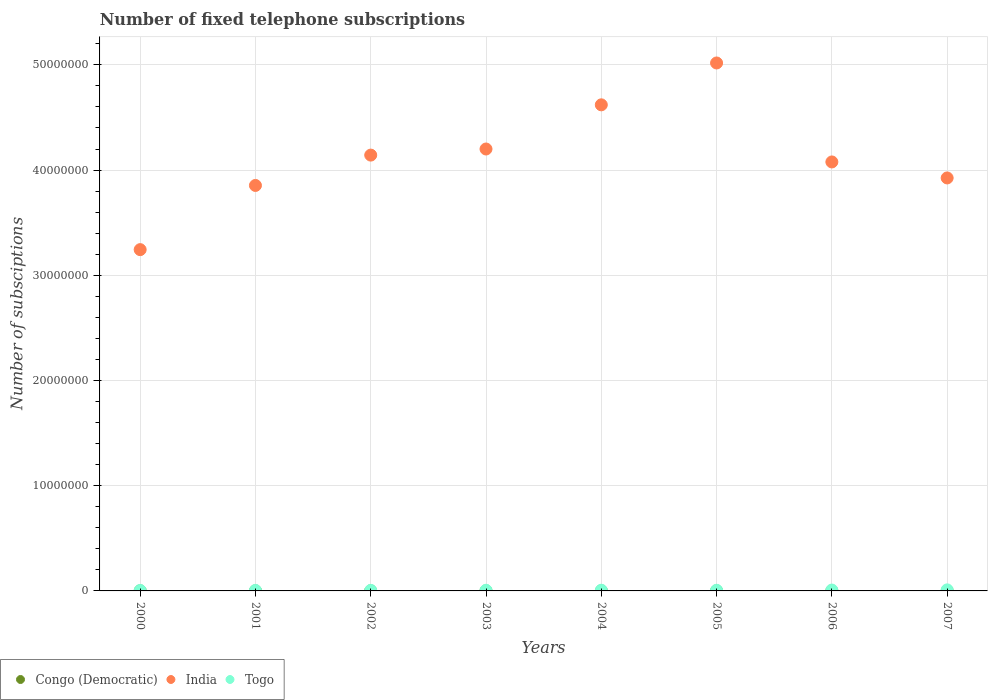How many different coloured dotlines are there?
Make the answer very short. 3. What is the number of fixed telephone subscriptions in India in 2005?
Make the answer very short. 5.02e+07. Across all years, what is the maximum number of fixed telephone subscriptions in India?
Your response must be concise. 5.02e+07. Across all years, what is the minimum number of fixed telephone subscriptions in India?
Offer a terse response. 3.24e+07. In which year was the number of fixed telephone subscriptions in India maximum?
Provide a succinct answer. 2005. In which year was the number of fixed telephone subscriptions in Togo minimum?
Offer a terse response. 2000. What is the total number of fixed telephone subscriptions in India in the graph?
Offer a very short reply. 3.31e+08. What is the difference between the number of fixed telephone subscriptions in India in 2002 and that in 2007?
Provide a short and direct response. 2.17e+06. What is the difference between the number of fixed telephone subscriptions in India in 2000 and the number of fixed telephone subscriptions in Congo (Democratic) in 2001?
Your answer should be compact. 3.24e+07. What is the average number of fixed telephone subscriptions in Congo (Democratic) per year?
Make the answer very short. 9228.25. In the year 2004, what is the difference between the number of fixed telephone subscriptions in India and number of fixed telephone subscriptions in Togo?
Make the answer very short. 4.61e+07. What is the ratio of the number of fixed telephone subscriptions in Congo (Democratic) in 2001 to that in 2006?
Ensure brevity in your answer.  1.03. Is the number of fixed telephone subscriptions in Congo (Democratic) in 2002 less than that in 2004?
Your response must be concise. Yes. Is the difference between the number of fixed telephone subscriptions in India in 2002 and 2005 greater than the difference between the number of fixed telephone subscriptions in Togo in 2002 and 2005?
Give a very brief answer. No. What is the difference between the highest and the lowest number of fixed telephone subscriptions in Congo (Democratic)?
Give a very brief answer. 7079. In how many years, is the number of fixed telephone subscriptions in Congo (Democratic) greater than the average number of fixed telephone subscriptions in Congo (Democratic) taken over all years?
Your answer should be compact. 7. Is the sum of the number of fixed telephone subscriptions in Congo (Democratic) in 2000 and 2001 greater than the maximum number of fixed telephone subscriptions in India across all years?
Provide a short and direct response. No. Is the number of fixed telephone subscriptions in Congo (Democratic) strictly greater than the number of fixed telephone subscriptions in India over the years?
Your answer should be compact. No. Does the graph contain any zero values?
Your answer should be very brief. No. Does the graph contain grids?
Provide a short and direct response. Yes. Where does the legend appear in the graph?
Offer a very short reply. Bottom left. What is the title of the graph?
Provide a succinct answer. Number of fixed telephone subscriptions. What is the label or title of the Y-axis?
Your answer should be very brief. Number of subsciptions. What is the Number of subsciptions of Congo (Democratic) in 2000?
Provide a short and direct response. 9810. What is the Number of subsciptions of India in 2000?
Your response must be concise. 3.24e+07. What is the Number of subsciptions in Togo in 2000?
Provide a short and direct response. 4.28e+04. What is the Number of subsciptions of Congo (Democratic) in 2001?
Give a very brief answer. 9980. What is the Number of subsciptions of India in 2001?
Offer a terse response. 3.85e+07. What is the Number of subsciptions in Togo in 2001?
Provide a succinct answer. 4.84e+04. What is the Number of subsciptions in India in 2002?
Your response must be concise. 4.14e+07. What is the Number of subsciptions of Togo in 2002?
Give a very brief answer. 5.12e+04. What is the Number of subsciptions in Congo (Democratic) in 2003?
Your answer should be compact. 9733. What is the Number of subsciptions in India in 2003?
Offer a very short reply. 4.20e+07. What is the Number of subsciptions in Togo in 2003?
Offer a very short reply. 6.11e+04. What is the Number of subsciptions of Congo (Democratic) in 2004?
Your answer should be compact. 1.05e+04. What is the Number of subsciptions in India in 2004?
Offer a terse response. 4.62e+07. What is the Number of subsciptions of Togo in 2004?
Offer a very short reply. 6.59e+04. What is the Number of subsciptions of Congo (Democratic) in 2005?
Your answer should be very brief. 1.06e+04. What is the Number of subsciptions in India in 2005?
Provide a succinct answer. 5.02e+07. What is the Number of subsciptions of Togo in 2005?
Provide a short and direct response. 6.28e+04. What is the Number of subsciptions in Congo (Democratic) in 2006?
Offer a very short reply. 9700. What is the Number of subsciptions of India in 2006?
Offer a very short reply. 4.08e+07. What is the Number of subsciptions of Togo in 2006?
Your answer should be very brief. 8.21e+04. What is the Number of subsciptions of Congo (Democratic) in 2007?
Your response must be concise. 3500. What is the Number of subsciptions of India in 2007?
Provide a short and direct response. 3.92e+07. What is the Number of subsciptions in Togo in 2007?
Keep it short and to the point. 9.95e+04. Across all years, what is the maximum Number of subsciptions of Congo (Democratic)?
Offer a very short reply. 1.06e+04. Across all years, what is the maximum Number of subsciptions in India?
Keep it short and to the point. 5.02e+07. Across all years, what is the maximum Number of subsciptions of Togo?
Provide a short and direct response. 9.95e+04. Across all years, what is the minimum Number of subsciptions of Congo (Democratic)?
Provide a succinct answer. 3500. Across all years, what is the minimum Number of subsciptions in India?
Keep it short and to the point. 3.24e+07. Across all years, what is the minimum Number of subsciptions of Togo?
Offer a terse response. 4.28e+04. What is the total Number of subsciptions in Congo (Democratic) in the graph?
Provide a succinct answer. 7.38e+04. What is the total Number of subsciptions of India in the graph?
Keep it short and to the point. 3.31e+08. What is the total Number of subsciptions of Togo in the graph?
Ensure brevity in your answer.  5.14e+05. What is the difference between the Number of subsciptions of Congo (Democratic) in 2000 and that in 2001?
Provide a short and direct response. -170. What is the difference between the Number of subsciptions of India in 2000 and that in 2001?
Keep it short and to the point. -6.10e+06. What is the difference between the Number of subsciptions in Togo in 2000 and that in 2001?
Your answer should be very brief. -5621. What is the difference between the Number of subsciptions in Congo (Democratic) in 2000 and that in 2002?
Ensure brevity in your answer.  -190. What is the difference between the Number of subsciptions of India in 2000 and that in 2002?
Provide a succinct answer. -8.98e+06. What is the difference between the Number of subsciptions in Togo in 2000 and that in 2002?
Offer a terse response. -8393. What is the difference between the Number of subsciptions in Congo (Democratic) in 2000 and that in 2003?
Your answer should be compact. 77. What is the difference between the Number of subsciptions in India in 2000 and that in 2003?
Keep it short and to the point. -9.56e+06. What is the difference between the Number of subsciptions in Togo in 2000 and that in 2003?
Make the answer very short. -1.83e+04. What is the difference between the Number of subsciptions in Congo (Democratic) in 2000 and that in 2004?
Give a very brief answer. -714. What is the difference between the Number of subsciptions of India in 2000 and that in 2004?
Offer a very short reply. -1.38e+07. What is the difference between the Number of subsciptions of Togo in 2000 and that in 2004?
Offer a terse response. -2.32e+04. What is the difference between the Number of subsciptions in Congo (Democratic) in 2000 and that in 2005?
Give a very brief answer. -769. What is the difference between the Number of subsciptions in India in 2000 and that in 2005?
Offer a very short reply. -1.77e+07. What is the difference between the Number of subsciptions in Togo in 2000 and that in 2005?
Make the answer very short. -2.01e+04. What is the difference between the Number of subsciptions in Congo (Democratic) in 2000 and that in 2006?
Offer a very short reply. 110. What is the difference between the Number of subsciptions in India in 2000 and that in 2006?
Your response must be concise. -8.33e+06. What is the difference between the Number of subsciptions in Togo in 2000 and that in 2006?
Your response must be concise. -3.93e+04. What is the difference between the Number of subsciptions of Congo (Democratic) in 2000 and that in 2007?
Ensure brevity in your answer.  6310. What is the difference between the Number of subsciptions of India in 2000 and that in 2007?
Ensure brevity in your answer.  -6.81e+06. What is the difference between the Number of subsciptions of Togo in 2000 and that in 2007?
Ensure brevity in your answer.  -5.67e+04. What is the difference between the Number of subsciptions in India in 2001 and that in 2002?
Give a very brief answer. -2.88e+06. What is the difference between the Number of subsciptions of Togo in 2001 and that in 2002?
Provide a succinct answer. -2772. What is the difference between the Number of subsciptions in Congo (Democratic) in 2001 and that in 2003?
Keep it short and to the point. 247. What is the difference between the Number of subsciptions in India in 2001 and that in 2003?
Provide a short and direct response. -3.46e+06. What is the difference between the Number of subsciptions of Togo in 2001 and that in 2003?
Offer a very short reply. -1.27e+04. What is the difference between the Number of subsciptions in Congo (Democratic) in 2001 and that in 2004?
Give a very brief answer. -544. What is the difference between the Number of subsciptions in India in 2001 and that in 2004?
Your response must be concise. -7.66e+06. What is the difference between the Number of subsciptions of Togo in 2001 and that in 2004?
Give a very brief answer. -1.76e+04. What is the difference between the Number of subsciptions of Congo (Democratic) in 2001 and that in 2005?
Make the answer very short. -599. What is the difference between the Number of subsciptions in India in 2001 and that in 2005?
Your response must be concise. -1.16e+07. What is the difference between the Number of subsciptions in Togo in 2001 and that in 2005?
Make the answer very short. -1.44e+04. What is the difference between the Number of subsciptions of Congo (Democratic) in 2001 and that in 2006?
Keep it short and to the point. 280. What is the difference between the Number of subsciptions in India in 2001 and that in 2006?
Provide a succinct answer. -2.23e+06. What is the difference between the Number of subsciptions in Togo in 2001 and that in 2006?
Provide a short and direct response. -3.37e+04. What is the difference between the Number of subsciptions of Congo (Democratic) in 2001 and that in 2007?
Make the answer very short. 6480. What is the difference between the Number of subsciptions in India in 2001 and that in 2007?
Provide a short and direct response. -7.14e+05. What is the difference between the Number of subsciptions of Togo in 2001 and that in 2007?
Your response must be concise. -5.11e+04. What is the difference between the Number of subsciptions of Congo (Democratic) in 2002 and that in 2003?
Keep it short and to the point. 267. What is the difference between the Number of subsciptions of India in 2002 and that in 2003?
Offer a very short reply. -5.80e+05. What is the difference between the Number of subsciptions of Togo in 2002 and that in 2003?
Make the answer very short. -9943. What is the difference between the Number of subsciptions of Congo (Democratic) in 2002 and that in 2004?
Make the answer very short. -524. What is the difference between the Number of subsciptions in India in 2002 and that in 2004?
Ensure brevity in your answer.  -4.78e+06. What is the difference between the Number of subsciptions of Togo in 2002 and that in 2004?
Provide a short and direct response. -1.48e+04. What is the difference between the Number of subsciptions in Congo (Democratic) in 2002 and that in 2005?
Your answer should be very brief. -579. What is the difference between the Number of subsciptions in India in 2002 and that in 2005?
Your answer should be compact. -8.76e+06. What is the difference between the Number of subsciptions of Togo in 2002 and that in 2005?
Make the answer very short. -1.17e+04. What is the difference between the Number of subsciptions of Congo (Democratic) in 2002 and that in 2006?
Provide a short and direct response. 300. What is the difference between the Number of subsciptions in India in 2002 and that in 2006?
Your response must be concise. 6.50e+05. What is the difference between the Number of subsciptions of Togo in 2002 and that in 2006?
Give a very brief answer. -3.09e+04. What is the difference between the Number of subsciptions in Congo (Democratic) in 2002 and that in 2007?
Your response must be concise. 6500. What is the difference between the Number of subsciptions of India in 2002 and that in 2007?
Ensure brevity in your answer.  2.17e+06. What is the difference between the Number of subsciptions of Togo in 2002 and that in 2007?
Keep it short and to the point. -4.83e+04. What is the difference between the Number of subsciptions in Congo (Democratic) in 2003 and that in 2004?
Make the answer very short. -791. What is the difference between the Number of subsciptions in India in 2003 and that in 2004?
Make the answer very short. -4.20e+06. What is the difference between the Number of subsciptions in Togo in 2003 and that in 2004?
Keep it short and to the point. -4850. What is the difference between the Number of subsciptions of Congo (Democratic) in 2003 and that in 2005?
Your answer should be very brief. -846. What is the difference between the Number of subsciptions in India in 2003 and that in 2005?
Provide a short and direct response. -8.18e+06. What is the difference between the Number of subsciptions in Togo in 2003 and that in 2005?
Your response must be concise. -1732. What is the difference between the Number of subsciptions in Congo (Democratic) in 2003 and that in 2006?
Ensure brevity in your answer.  33. What is the difference between the Number of subsciptions of India in 2003 and that in 2006?
Your answer should be very brief. 1.23e+06. What is the difference between the Number of subsciptions in Togo in 2003 and that in 2006?
Your answer should be compact. -2.10e+04. What is the difference between the Number of subsciptions in Congo (Democratic) in 2003 and that in 2007?
Provide a succinct answer. 6233. What is the difference between the Number of subsciptions in India in 2003 and that in 2007?
Your response must be concise. 2.75e+06. What is the difference between the Number of subsciptions of Togo in 2003 and that in 2007?
Your answer should be compact. -3.84e+04. What is the difference between the Number of subsciptions of Congo (Democratic) in 2004 and that in 2005?
Ensure brevity in your answer.  -55. What is the difference between the Number of subsciptions of India in 2004 and that in 2005?
Ensure brevity in your answer.  -3.98e+06. What is the difference between the Number of subsciptions in Togo in 2004 and that in 2005?
Give a very brief answer. 3118. What is the difference between the Number of subsciptions in Congo (Democratic) in 2004 and that in 2006?
Your answer should be very brief. 824. What is the difference between the Number of subsciptions in India in 2004 and that in 2006?
Give a very brief answer. 5.43e+06. What is the difference between the Number of subsciptions in Togo in 2004 and that in 2006?
Your answer should be very brief. -1.61e+04. What is the difference between the Number of subsciptions in Congo (Democratic) in 2004 and that in 2007?
Your response must be concise. 7024. What is the difference between the Number of subsciptions in India in 2004 and that in 2007?
Provide a short and direct response. 6.95e+06. What is the difference between the Number of subsciptions in Togo in 2004 and that in 2007?
Your answer should be compact. -3.35e+04. What is the difference between the Number of subsciptions of Congo (Democratic) in 2005 and that in 2006?
Your response must be concise. 879. What is the difference between the Number of subsciptions in India in 2005 and that in 2006?
Your response must be concise. 9.41e+06. What is the difference between the Number of subsciptions in Togo in 2005 and that in 2006?
Provide a succinct answer. -1.92e+04. What is the difference between the Number of subsciptions of Congo (Democratic) in 2005 and that in 2007?
Offer a terse response. 7079. What is the difference between the Number of subsciptions in India in 2005 and that in 2007?
Your response must be concise. 1.09e+07. What is the difference between the Number of subsciptions in Togo in 2005 and that in 2007?
Ensure brevity in your answer.  -3.67e+04. What is the difference between the Number of subsciptions in Congo (Democratic) in 2006 and that in 2007?
Give a very brief answer. 6200. What is the difference between the Number of subsciptions of India in 2006 and that in 2007?
Your response must be concise. 1.52e+06. What is the difference between the Number of subsciptions of Togo in 2006 and that in 2007?
Your answer should be very brief. -1.74e+04. What is the difference between the Number of subsciptions of Congo (Democratic) in 2000 and the Number of subsciptions of India in 2001?
Your answer should be very brief. -3.85e+07. What is the difference between the Number of subsciptions in Congo (Democratic) in 2000 and the Number of subsciptions in Togo in 2001?
Make the answer very short. -3.86e+04. What is the difference between the Number of subsciptions of India in 2000 and the Number of subsciptions of Togo in 2001?
Offer a terse response. 3.24e+07. What is the difference between the Number of subsciptions in Congo (Democratic) in 2000 and the Number of subsciptions in India in 2002?
Your answer should be very brief. -4.14e+07. What is the difference between the Number of subsciptions in Congo (Democratic) in 2000 and the Number of subsciptions in Togo in 2002?
Provide a succinct answer. -4.13e+04. What is the difference between the Number of subsciptions in India in 2000 and the Number of subsciptions in Togo in 2002?
Your response must be concise. 3.24e+07. What is the difference between the Number of subsciptions in Congo (Democratic) in 2000 and the Number of subsciptions in India in 2003?
Make the answer very short. -4.20e+07. What is the difference between the Number of subsciptions of Congo (Democratic) in 2000 and the Number of subsciptions of Togo in 2003?
Offer a terse response. -5.13e+04. What is the difference between the Number of subsciptions in India in 2000 and the Number of subsciptions in Togo in 2003?
Give a very brief answer. 3.24e+07. What is the difference between the Number of subsciptions of Congo (Democratic) in 2000 and the Number of subsciptions of India in 2004?
Offer a terse response. -4.62e+07. What is the difference between the Number of subsciptions of Congo (Democratic) in 2000 and the Number of subsciptions of Togo in 2004?
Offer a very short reply. -5.61e+04. What is the difference between the Number of subsciptions in India in 2000 and the Number of subsciptions in Togo in 2004?
Provide a short and direct response. 3.24e+07. What is the difference between the Number of subsciptions of Congo (Democratic) in 2000 and the Number of subsciptions of India in 2005?
Give a very brief answer. -5.02e+07. What is the difference between the Number of subsciptions in Congo (Democratic) in 2000 and the Number of subsciptions in Togo in 2005?
Provide a short and direct response. -5.30e+04. What is the difference between the Number of subsciptions in India in 2000 and the Number of subsciptions in Togo in 2005?
Offer a terse response. 3.24e+07. What is the difference between the Number of subsciptions in Congo (Democratic) in 2000 and the Number of subsciptions in India in 2006?
Your response must be concise. -4.08e+07. What is the difference between the Number of subsciptions in Congo (Democratic) in 2000 and the Number of subsciptions in Togo in 2006?
Make the answer very short. -7.22e+04. What is the difference between the Number of subsciptions in India in 2000 and the Number of subsciptions in Togo in 2006?
Keep it short and to the point. 3.24e+07. What is the difference between the Number of subsciptions of Congo (Democratic) in 2000 and the Number of subsciptions of India in 2007?
Provide a succinct answer. -3.92e+07. What is the difference between the Number of subsciptions of Congo (Democratic) in 2000 and the Number of subsciptions of Togo in 2007?
Make the answer very short. -8.97e+04. What is the difference between the Number of subsciptions of India in 2000 and the Number of subsciptions of Togo in 2007?
Offer a terse response. 3.23e+07. What is the difference between the Number of subsciptions in Congo (Democratic) in 2001 and the Number of subsciptions in India in 2002?
Offer a very short reply. -4.14e+07. What is the difference between the Number of subsciptions in Congo (Democratic) in 2001 and the Number of subsciptions in Togo in 2002?
Your answer should be very brief. -4.12e+04. What is the difference between the Number of subsciptions in India in 2001 and the Number of subsciptions in Togo in 2002?
Ensure brevity in your answer.  3.85e+07. What is the difference between the Number of subsciptions of Congo (Democratic) in 2001 and the Number of subsciptions of India in 2003?
Keep it short and to the point. -4.20e+07. What is the difference between the Number of subsciptions of Congo (Democratic) in 2001 and the Number of subsciptions of Togo in 2003?
Make the answer very short. -5.11e+04. What is the difference between the Number of subsciptions of India in 2001 and the Number of subsciptions of Togo in 2003?
Ensure brevity in your answer.  3.85e+07. What is the difference between the Number of subsciptions of Congo (Democratic) in 2001 and the Number of subsciptions of India in 2004?
Your answer should be very brief. -4.62e+07. What is the difference between the Number of subsciptions of Congo (Democratic) in 2001 and the Number of subsciptions of Togo in 2004?
Offer a terse response. -5.60e+04. What is the difference between the Number of subsciptions in India in 2001 and the Number of subsciptions in Togo in 2004?
Offer a very short reply. 3.85e+07. What is the difference between the Number of subsciptions in Congo (Democratic) in 2001 and the Number of subsciptions in India in 2005?
Your answer should be very brief. -5.02e+07. What is the difference between the Number of subsciptions in Congo (Democratic) in 2001 and the Number of subsciptions in Togo in 2005?
Offer a very short reply. -5.29e+04. What is the difference between the Number of subsciptions in India in 2001 and the Number of subsciptions in Togo in 2005?
Provide a succinct answer. 3.85e+07. What is the difference between the Number of subsciptions in Congo (Democratic) in 2001 and the Number of subsciptions in India in 2006?
Ensure brevity in your answer.  -4.08e+07. What is the difference between the Number of subsciptions in Congo (Democratic) in 2001 and the Number of subsciptions in Togo in 2006?
Provide a short and direct response. -7.21e+04. What is the difference between the Number of subsciptions of India in 2001 and the Number of subsciptions of Togo in 2006?
Make the answer very short. 3.85e+07. What is the difference between the Number of subsciptions in Congo (Democratic) in 2001 and the Number of subsciptions in India in 2007?
Provide a succinct answer. -3.92e+07. What is the difference between the Number of subsciptions in Congo (Democratic) in 2001 and the Number of subsciptions in Togo in 2007?
Offer a terse response. -8.95e+04. What is the difference between the Number of subsciptions in India in 2001 and the Number of subsciptions in Togo in 2007?
Ensure brevity in your answer.  3.84e+07. What is the difference between the Number of subsciptions in Congo (Democratic) in 2002 and the Number of subsciptions in India in 2003?
Give a very brief answer. -4.20e+07. What is the difference between the Number of subsciptions in Congo (Democratic) in 2002 and the Number of subsciptions in Togo in 2003?
Ensure brevity in your answer.  -5.11e+04. What is the difference between the Number of subsciptions in India in 2002 and the Number of subsciptions in Togo in 2003?
Offer a very short reply. 4.14e+07. What is the difference between the Number of subsciptions of Congo (Democratic) in 2002 and the Number of subsciptions of India in 2004?
Your response must be concise. -4.62e+07. What is the difference between the Number of subsciptions of Congo (Democratic) in 2002 and the Number of subsciptions of Togo in 2004?
Give a very brief answer. -5.59e+04. What is the difference between the Number of subsciptions in India in 2002 and the Number of subsciptions in Togo in 2004?
Offer a terse response. 4.14e+07. What is the difference between the Number of subsciptions of Congo (Democratic) in 2002 and the Number of subsciptions of India in 2005?
Give a very brief answer. -5.02e+07. What is the difference between the Number of subsciptions of Congo (Democratic) in 2002 and the Number of subsciptions of Togo in 2005?
Your response must be concise. -5.28e+04. What is the difference between the Number of subsciptions of India in 2002 and the Number of subsciptions of Togo in 2005?
Make the answer very short. 4.14e+07. What is the difference between the Number of subsciptions of Congo (Democratic) in 2002 and the Number of subsciptions of India in 2006?
Give a very brief answer. -4.08e+07. What is the difference between the Number of subsciptions in Congo (Democratic) in 2002 and the Number of subsciptions in Togo in 2006?
Make the answer very short. -7.21e+04. What is the difference between the Number of subsciptions of India in 2002 and the Number of subsciptions of Togo in 2006?
Your answer should be compact. 4.13e+07. What is the difference between the Number of subsciptions in Congo (Democratic) in 2002 and the Number of subsciptions in India in 2007?
Keep it short and to the point. -3.92e+07. What is the difference between the Number of subsciptions in Congo (Democratic) in 2002 and the Number of subsciptions in Togo in 2007?
Provide a short and direct response. -8.95e+04. What is the difference between the Number of subsciptions of India in 2002 and the Number of subsciptions of Togo in 2007?
Make the answer very short. 4.13e+07. What is the difference between the Number of subsciptions in Congo (Democratic) in 2003 and the Number of subsciptions in India in 2004?
Your response must be concise. -4.62e+07. What is the difference between the Number of subsciptions of Congo (Democratic) in 2003 and the Number of subsciptions of Togo in 2004?
Your response must be concise. -5.62e+04. What is the difference between the Number of subsciptions of India in 2003 and the Number of subsciptions of Togo in 2004?
Ensure brevity in your answer.  4.19e+07. What is the difference between the Number of subsciptions of Congo (Democratic) in 2003 and the Number of subsciptions of India in 2005?
Keep it short and to the point. -5.02e+07. What is the difference between the Number of subsciptions in Congo (Democratic) in 2003 and the Number of subsciptions in Togo in 2005?
Your answer should be compact. -5.31e+04. What is the difference between the Number of subsciptions in India in 2003 and the Number of subsciptions in Togo in 2005?
Make the answer very short. 4.19e+07. What is the difference between the Number of subsciptions of Congo (Democratic) in 2003 and the Number of subsciptions of India in 2006?
Your response must be concise. -4.08e+07. What is the difference between the Number of subsciptions in Congo (Democratic) in 2003 and the Number of subsciptions in Togo in 2006?
Ensure brevity in your answer.  -7.23e+04. What is the difference between the Number of subsciptions of India in 2003 and the Number of subsciptions of Togo in 2006?
Provide a short and direct response. 4.19e+07. What is the difference between the Number of subsciptions of Congo (Democratic) in 2003 and the Number of subsciptions of India in 2007?
Your answer should be very brief. -3.92e+07. What is the difference between the Number of subsciptions of Congo (Democratic) in 2003 and the Number of subsciptions of Togo in 2007?
Your response must be concise. -8.98e+04. What is the difference between the Number of subsciptions of India in 2003 and the Number of subsciptions of Togo in 2007?
Your response must be concise. 4.19e+07. What is the difference between the Number of subsciptions in Congo (Democratic) in 2004 and the Number of subsciptions in India in 2005?
Your response must be concise. -5.02e+07. What is the difference between the Number of subsciptions of Congo (Democratic) in 2004 and the Number of subsciptions of Togo in 2005?
Your answer should be compact. -5.23e+04. What is the difference between the Number of subsciptions in India in 2004 and the Number of subsciptions in Togo in 2005?
Keep it short and to the point. 4.61e+07. What is the difference between the Number of subsciptions in Congo (Democratic) in 2004 and the Number of subsciptions in India in 2006?
Your answer should be compact. -4.08e+07. What is the difference between the Number of subsciptions in Congo (Democratic) in 2004 and the Number of subsciptions in Togo in 2006?
Give a very brief answer. -7.15e+04. What is the difference between the Number of subsciptions of India in 2004 and the Number of subsciptions of Togo in 2006?
Your answer should be compact. 4.61e+07. What is the difference between the Number of subsciptions in Congo (Democratic) in 2004 and the Number of subsciptions in India in 2007?
Provide a succinct answer. -3.92e+07. What is the difference between the Number of subsciptions in Congo (Democratic) in 2004 and the Number of subsciptions in Togo in 2007?
Your response must be concise. -8.90e+04. What is the difference between the Number of subsciptions in India in 2004 and the Number of subsciptions in Togo in 2007?
Provide a succinct answer. 4.61e+07. What is the difference between the Number of subsciptions in Congo (Democratic) in 2005 and the Number of subsciptions in India in 2006?
Offer a very short reply. -4.08e+07. What is the difference between the Number of subsciptions in Congo (Democratic) in 2005 and the Number of subsciptions in Togo in 2006?
Your response must be concise. -7.15e+04. What is the difference between the Number of subsciptions in India in 2005 and the Number of subsciptions in Togo in 2006?
Keep it short and to the point. 5.01e+07. What is the difference between the Number of subsciptions of Congo (Democratic) in 2005 and the Number of subsciptions of India in 2007?
Your response must be concise. -3.92e+07. What is the difference between the Number of subsciptions in Congo (Democratic) in 2005 and the Number of subsciptions in Togo in 2007?
Give a very brief answer. -8.89e+04. What is the difference between the Number of subsciptions of India in 2005 and the Number of subsciptions of Togo in 2007?
Offer a terse response. 5.01e+07. What is the difference between the Number of subsciptions of Congo (Democratic) in 2006 and the Number of subsciptions of India in 2007?
Your response must be concise. -3.92e+07. What is the difference between the Number of subsciptions in Congo (Democratic) in 2006 and the Number of subsciptions in Togo in 2007?
Your answer should be very brief. -8.98e+04. What is the difference between the Number of subsciptions of India in 2006 and the Number of subsciptions of Togo in 2007?
Keep it short and to the point. 4.07e+07. What is the average Number of subsciptions of Congo (Democratic) per year?
Offer a very short reply. 9228.25. What is the average Number of subsciptions in India per year?
Offer a very short reply. 4.13e+07. What is the average Number of subsciptions in Togo per year?
Offer a very short reply. 6.42e+04. In the year 2000, what is the difference between the Number of subsciptions in Congo (Democratic) and Number of subsciptions in India?
Your answer should be very brief. -3.24e+07. In the year 2000, what is the difference between the Number of subsciptions in Congo (Democratic) and Number of subsciptions in Togo?
Your answer should be very brief. -3.30e+04. In the year 2000, what is the difference between the Number of subsciptions of India and Number of subsciptions of Togo?
Your response must be concise. 3.24e+07. In the year 2001, what is the difference between the Number of subsciptions of Congo (Democratic) and Number of subsciptions of India?
Keep it short and to the point. -3.85e+07. In the year 2001, what is the difference between the Number of subsciptions of Congo (Democratic) and Number of subsciptions of Togo?
Provide a short and direct response. -3.84e+04. In the year 2001, what is the difference between the Number of subsciptions of India and Number of subsciptions of Togo?
Make the answer very short. 3.85e+07. In the year 2002, what is the difference between the Number of subsciptions in Congo (Democratic) and Number of subsciptions in India?
Provide a short and direct response. -4.14e+07. In the year 2002, what is the difference between the Number of subsciptions of Congo (Democratic) and Number of subsciptions of Togo?
Give a very brief answer. -4.12e+04. In the year 2002, what is the difference between the Number of subsciptions of India and Number of subsciptions of Togo?
Make the answer very short. 4.14e+07. In the year 2003, what is the difference between the Number of subsciptions in Congo (Democratic) and Number of subsciptions in India?
Keep it short and to the point. -4.20e+07. In the year 2003, what is the difference between the Number of subsciptions in Congo (Democratic) and Number of subsciptions in Togo?
Offer a very short reply. -5.14e+04. In the year 2003, what is the difference between the Number of subsciptions of India and Number of subsciptions of Togo?
Keep it short and to the point. 4.19e+07. In the year 2004, what is the difference between the Number of subsciptions of Congo (Democratic) and Number of subsciptions of India?
Give a very brief answer. -4.62e+07. In the year 2004, what is the difference between the Number of subsciptions in Congo (Democratic) and Number of subsciptions in Togo?
Your response must be concise. -5.54e+04. In the year 2004, what is the difference between the Number of subsciptions of India and Number of subsciptions of Togo?
Your response must be concise. 4.61e+07. In the year 2005, what is the difference between the Number of subsciptions in Congo (Democratic) and Number of subsciptions in India?
Your answer should be very brief. -5.02e+07. In the year 2005, what is the difference between the Number of subsciptions in Congo (Democratic) and Number of subsciptions in Togo?
Make the answer very short. -5.23e+04. In the year 2005, what is the difference between the Number of subsciptions of India and Number of subsciptions of Togo?
Offer a terse response. 5.01e+07. In the year 2006, what is the difference between the Number of subsciptions in Congo (Democratic) and Number of subsciptions in India?
Keep it short and to the point. -4.08e+07. In the year 2006, what is the difference between the Number of subsciptions in Congo (Democratic) and Number of subsciptions in Togo?
Your answer should be very brief. -7.24e+04. In the year 2006, what is the difference between the Number of subsciptions of India and Number of subsciptions of Togo?
Your response must be concise. 4.07e+07. In the year 2007, what is the difference between the Number of subsciptions in Congo (Democratic) and Number of subsciptions in India?
Make the answer very short. -3.92e+07. In the year 2007, what is the difference between the Number of subsciptions in Congo (Democratic) and Number of subsciptions in Togo?
Give a very brief answer. -9.60e+04. In the year 2007, what is the difference between the Number of subsciptions in India and Number of subsciptions in Togo?
Your response must be concise. 3.92e+07. What is the ratio of the Number of subsciptions of Congo (Democratic) in 2000 to that in 2001?
Keep it short and to the point. 0.98. What is the ratio of the Number of subsciptions in India in 2000 to that in 2001?
Make the answer very short. 0.84. What is the ratio of the Number of subsciptions of Togo in 2000 to that in 2001?
Your response must be concise. 0.88. What is the ratio of the Number of subsciptions in Congo (Democratic) in 2000 to that in 2002?
Give a very brief answer. 0.98. What is the ratio of the Number of subsciptions in India in 2000 to that in 2002?
Your answer should be very brief. 0.78. What is the ratio of the Number of subsciptions of Togo in 2000 to that in 2002?
Give a very brief answer. 0.84. What is the ratio of the Number of subsciptions in Congo (Democratic) in 2000 to that in 2003?
Keep it short and to the point. 1.01. What is the ratio of the Number of subsciptions of India in 2000 to that in 2003?
Offer a terse response. 0.77. What is the ratio of the Number of subsciptions of Togo in 2000 to that in 2003?
Your answer should be compact. 0.7. What is the ratio of the Number of subsciptions in Congo (Democratic) in 2000 to that in 2004?
Provide a short and direct response. 0.93. What is the ratio of the Number of subsciptions of India in 2000 to that in 2004?
Offer a terse response. 0.7. What is the ratio of the Number of subsciptions in Togo in 2000 to that in 2004?
Make the answer very short. 0.65. What is the ratio of the Number of subsciptions in Congo (Democratic) in 2000 to that in 2005?
Make the answer very short. 0.93. What is the ratio of the Number of subsciptions in India in 2000 to that in 2005?
Offer a terse response. 0.65. What is the ratio of the Number of subsciptions of Togo in 2000 to that in 2005?
Keep it short and to the point. 0.68. What is the ratio of the Number of subsciptions in Congo (Democratic) in 2000 to that in 2006?
Give a very brief answer. 1.01. What is the ratio of the Number of subsciptions in India in 2000 to that in 2006?
Provide a short and direct response. 0.8. What is the ratio of the Number of subsciptions of Togo in 2000 to that in 2006?
Make the answer very short. 0.52. What is the ratio of the Number of subsciptions in Congo (Democratic) in 2000 to that in 2007?
Give a very brief answer. 2.8. What is the ratio of the Number of subsciptions in India in 2000 to that in 2007?
Offer a terse response. 0.83. What is the ratio of the Number of subsciptions of Togo in 2000 to that in 2007?
Offer a very short reply. 0.43. What is the ratio of the Number of subsciptions in Congo (Democratic) in 2001 to that in 2002?
Your response must be concise. 1. What is the ratio of the Number of subsciptions of India in 2001 to that in 2002?
Your answer should be very brief. 0.93. What is the ratio of the Number of subsciptions in Togo in 2001 to that in 2002?
Offer a terse response. 0.95. What is the ratio of the Number of subsciptions in Congo (Democratic) in 2001 to that in 2003?
Provide a succinct answer. 1.03. What is the ratio of the Number of subsciptions of India in 2001 to that in 2003?
Your response must be concise. 0.92. What is the ratio of the Number of subsciptions in Togo in 2001 to that in 2003?
Ensure brevity in your answer.  0.79. What is the ratio of the Number of subsciptions in Congo (Democratic) in 2001 to that in 2004?
Give a very brief answer. 0.95. What is the ratio of the Number of subsciptions of India in 2001 to that in 2004?
Your answer should be very brief. 0.83. What is the ratio of the Number of subsciptions of Togo in 2001 to that in 2004?
Your response must be concise. 0.73. What is the ratio of the Number of subsciptions of Congo (Democratic) in 2001 to that in 2005?
Ensure brevity in your answer.  0.94. What is the ratio of the Number of subsciptions in India in 2001 to that in 2005?
Provide a short and direct response. 0.77. What is the ratio of the Number of subsciptions in Togo in 2001 to that in 2005?
Your answer should be compact. 0.77. What is the ratio of the Number of subsciptions in Congo (Democratic) in 2001 to that in 2006?
Make the answer very short. 1.03. What is the ratio of the Number of subsciptions of India in 2001 to that in 2006?
Offer a very short reply. 0.95. What is the ratio of the Number of subsciptions in Togo in 2001 to that in 2006?
Keep it short and to the point. 0.59. What is the ratio of the Number of subsciptions of Congo (Democratic) in 2001 to that in 2007?
Your response must be concise. 2.85. What is the ratio of the Number of subsciptions of India in 2001 to that in 2007?
Your response must be concise. 0.98. What is the ratio of the Number of subsciptions in Togo in 2001 to that in 2007?
Keep it short and to the point. 0.49. What is the ratio of the Number of subsciptions in Congo (Democratic) in 2002 to that in 2003?
Your answer should be very brief. 1.03. What is the ratio of the Number of subsciptions in India in 2002 to that in 2003?
Provide a short and direct response. 0.99. What is the ratio of the Number of subsciptions of Togo in 2002 to that in 2003?
Provide a short and direct response. 0.84. What is the ratio of the Number of subsciptions in Congo (Democratic) in 2002 to that in 2004?
Make the answer very short. 0.95. What is the ratio of the Number of subsciptions in India in 2002 to that in 2004?
Offer a terse response. 0.9. What is the ratio of the Number of subsciptions of Togo in 2002 to that in 2004?
Give a very brief answer. 0.78. What is the ratio of the Number of subsciptions of Congo (Democratic) in 2002 to that in 2005?
Your answer should be compact. 0.95. What is the ratio of the Number of subsciptions of India in 2002 to that in 2005?
Give a very brief answer. 0.83. What is the ratio of the Number of subsciptions in Togo in 2002 to that in 2005?
Your answer should be compact. 0.81. What is the ratio of the Number of subsciptions of Congo (Democratic) in 2002 to that in 2006?
Your answer should be very brief. 1.03. What is the ratio of the Number of subsciptions of India in 2002 to that in 2006?
Offer a very short reply. 1.02. What is the ratio of the Number of subsciptions in Togo in 2002 to that in 2006?
Make the answer very short. 0.62. What is the ratio of the Number of subsciptions in Congo (Democratic) in 2002 to that in 2007?
Ensure brevity in your answer.  2.86. What is the ratio of the Number of subsciptions of India in 2002 to that in 2007?
Your answer should be compact. 1.06. What is the ratio of the Number of subsciptions of Togo in 2002 to that in 2007?
Your answer should be very brief. 0.51. What is the ratio of the Number of subsciptions in Congo (Democratic) in 2003 to that in 2004?
Provide a succinct answer. 0.92. What is the ratio of the Number of subsciptions of Togo in 2003 to that in 2004?
Provide a short and direct response. 0.93. What is the ratio of the Number of subsciptions in Congo (Democratic) in 2003 to that in 2005?
Your response must be concise. 0.92. What is the ratio of the Number of subsciptions of India in 2003 to that in 2005?
Make the answer very short. 0.84. What is the ratio of the Number of subsciptions in Togo in 2003 to that in 2005?
Provide a succinct answer. 0.97. What is the ratio of the Number of subsciptions of India in 2003 to that in 2006?
Your answer should be very brief. 1.03. What is the ratio of the Number of subsciptions of Togo in 2003 to that in 2006?
Ensure brevity in your answer.  0.74. What is the ratio of the Number of subsciptions in Congo (Democratic) in 2003 to that in 2007?
Your answer should be very brief. 2.78. What is the ratio of the Number of subsciptions in India in 2003 to that in 2007?
Give a very brief answer. 1.07. What is the ratio of the Number of subsciptions in Togo in 2003 to that in 2007?
Make the answer very short. 0.61. What is the ratio of the Number of subsciptions of India in 2004 to that in 2005?
Provide a succinct answer. 0.92. What is the ratio of the Number of subsciptions in Togo in 2004 to that in 2005?
Offer a terse response. 1.05. What is the ratio of the Number of subsciptions of Congo (Democratic) in 2004 to that in 2006?
Keep it short and to the point. 1.08. What is the ratio of the Number of subsciptions in India in 2004 to that in 2006?
Make the answer very short. 1.13. What is the ratio of the Number of subsciptions of Togo in 2004 to that in 2006?
Offer a terse response. 0.8. What is the ratio of the Number of subsciptions of Congo (Democratic) in 2004 to that in 2007?
Make the answer very short. 3.01. What is the ratio of the Number of subsciptions in India in 2004 to that in 2007?
Give a very brief answer. 1.18. What is the ratio of the Number of subsciptions of Togo in 2004 to that in 2007?
Give a very brief answer. 0.66. What is the ratio of the Number of subsciptions of Congo (Democratic) in 2005 to that in 2006?
Keep it short and to the point. 1.09. What is the ratio of the Number of subsciptions of India in 2005 to that in 2006?
Provide a short and direct response. 1.23. What is the ratio of the Number of subsciptions in Togo in 2005 to that in 2006?
Your answer should be very brief. 0.77. What is the ratio of the Number of subsciptions of Congo (Democratic) in 2005 to that in 2007?
Your answer should be very brief. 3.02. What is the ratio of the Number of subsciptions in India in 2005 to that in 2007?
Your answer should be very brief. 1.28. What is the ratio of the Number of subsciptions of Togo in 2005 to that in 2007?
Provide a short and direct response. 0.63. What is the ratio of the Number of subsciptions of Congo (Democratic) in 2006 to that in 2007?
Ensure brevity in your answer.  2.77. What is the ratio of the Number of subsciptions of India in 2006 to that in 2007?
Provide a succinct answer. 1.04. What is the ratio of the Number of subsciptions in Togo in 2006 to that in 2007?
Your answer should be very brief. 0.82. What is the difference between the highest and the second highest Number of subsciptions in India?
Provide a succinct answer. 3.98e+06. What is the difference between the highest and the second highest Number of subsciptions of Togo?
Give a very brief answer. 1.74e+04. What is the difference between the highest and the lowest Number of subsciptions in Congo (Democratic)?
Make the answer very short. 7079. What is the difference between the highest and the lowest Number of subsciptions of India?
Make the answer very short. 1.77e+07. What is the difference between the highest and the lowest Number of subsciptions in Togo?
Your answer should be very brief. 5.67e+04. 